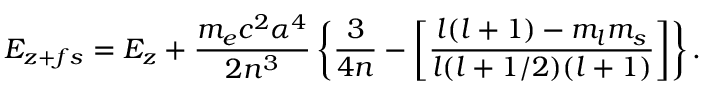Convert formula to latex. <formula><loc_0><loc_0><loc_500><loc_500>E _ { z + f s } = E _ { z } + { \frac { m _ { e } c ^ { 2 } \alpha ^ { 4 } } { 2 n ^ { 3 } } } \left \{ { \frac { 3 } { 4 n } } - \left [ { \frac { l ( l + 1 ) - m _ { l } m _ { s } } { l ( l + 1 / 2 ) ( l + 1 ) } } \right ] \right \} .</formula> 